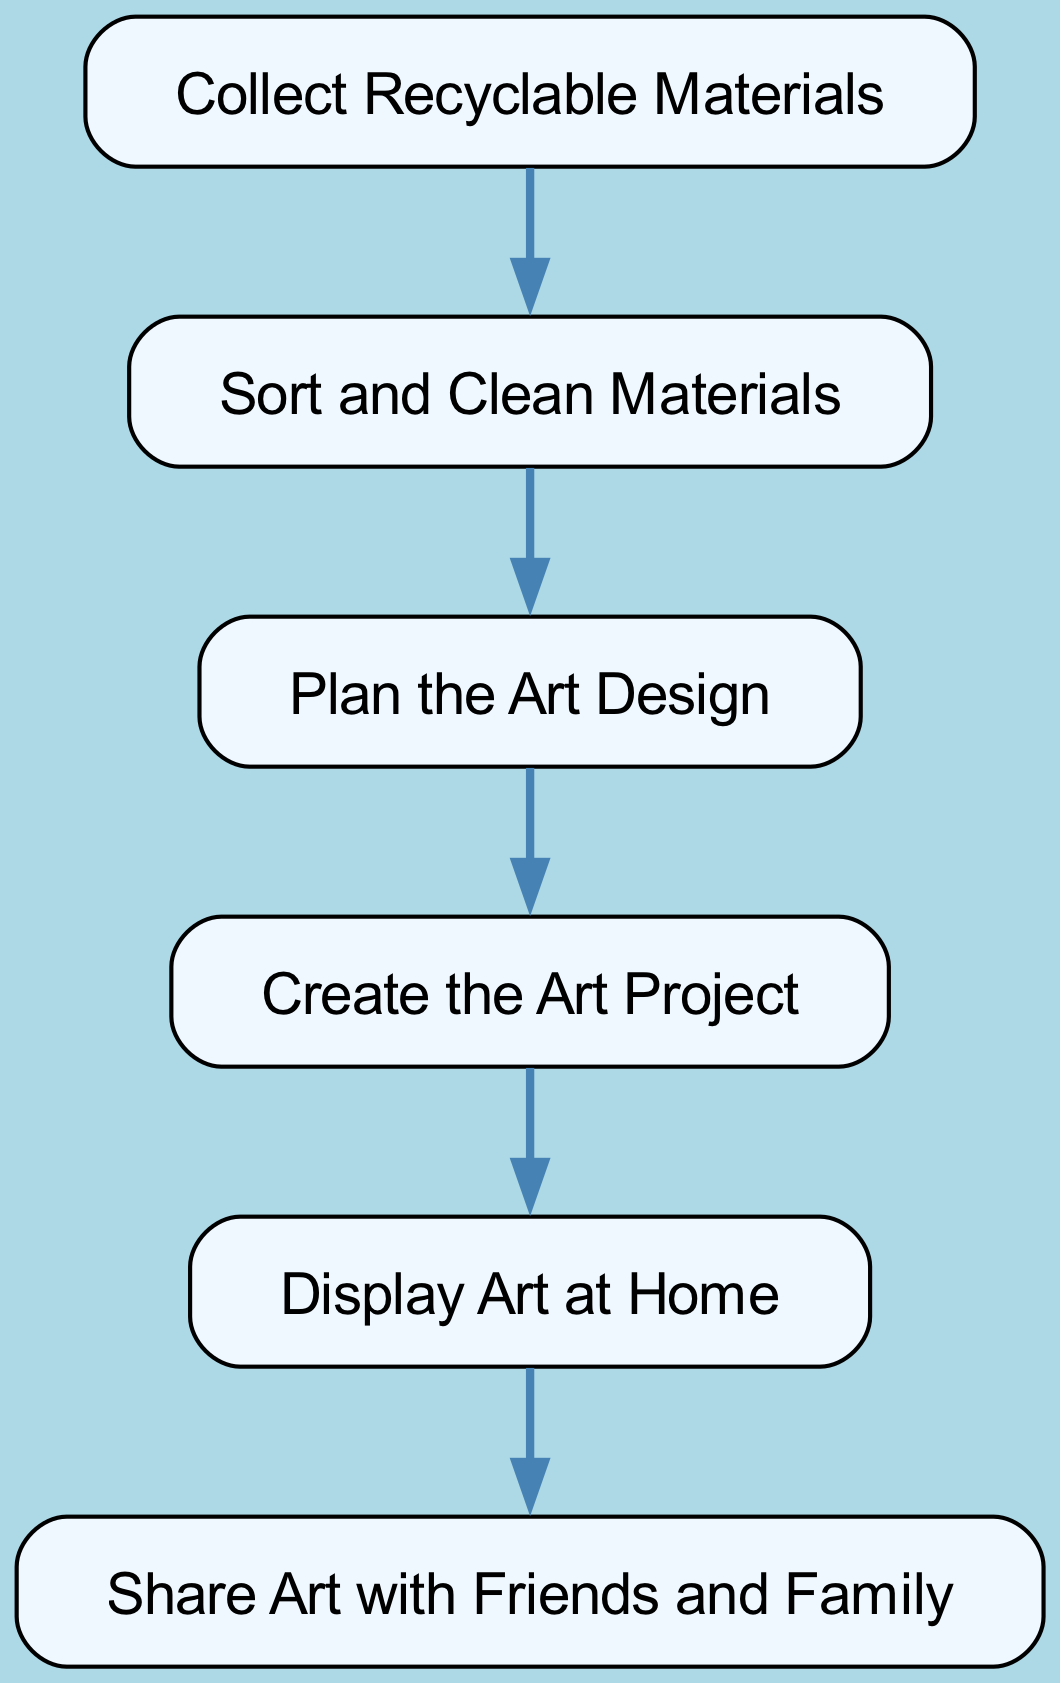What is the first step in the recycling process flow? The first step is indicated as the starting node of the directed graph, which is 'Collect Recyclable Materials'.
Answer: Collect Recyclable Materials How many nodes are present in the diagram? To find the total number of nodes, simply count each unique node listed in the 'nodes' section of the data. There are 6 nodes total.
Answer: 6 Which node comes after 'Sort and Clean Materials'? By following the direction of the arrows from 'Sort and Clean Materials', the next node is 'Plan the Art Design'.
Answer: Plan the Art Design What is the last step in the process flow? The last step is identified as the final node in the directed graph, which is 'Share Art with Friends and Family'.
Answer: Share Art with Friends and Family How many edges are there in the graph? To determine the number of edges, count the arrows (connections) between the nodes listed in the 'edges' section. There are 5 edges total.
Answer: 5 What do you do after creating the art project? The process flow indicates that after creating the art project, the next step is to 'Display Art at Home'.
Answer: Display Art at Home What is the relationship between 'Create Art' and 'Display Art'? There is a directed edge that connects 'Create Art' to 'Display Art', indicating that you display the art created in the previous step.
Answer: Display Art Which node follows 'Plan the Art Design'? Following the directed connection, 'Plan the Art Design' leads to the next node, which is 'Create the Art Project'.
Answer: Create the Art Project What are the nodes that have outgoing edges? The nodes with outgoing edges are 'Collect Materials', 'Sort Materials', 'Plan Design', and 'Create Art', as they each lead to another node in the direction of the diagram.
Answer: Collect Materials, Sort Materials, Plan Design, Create Art 